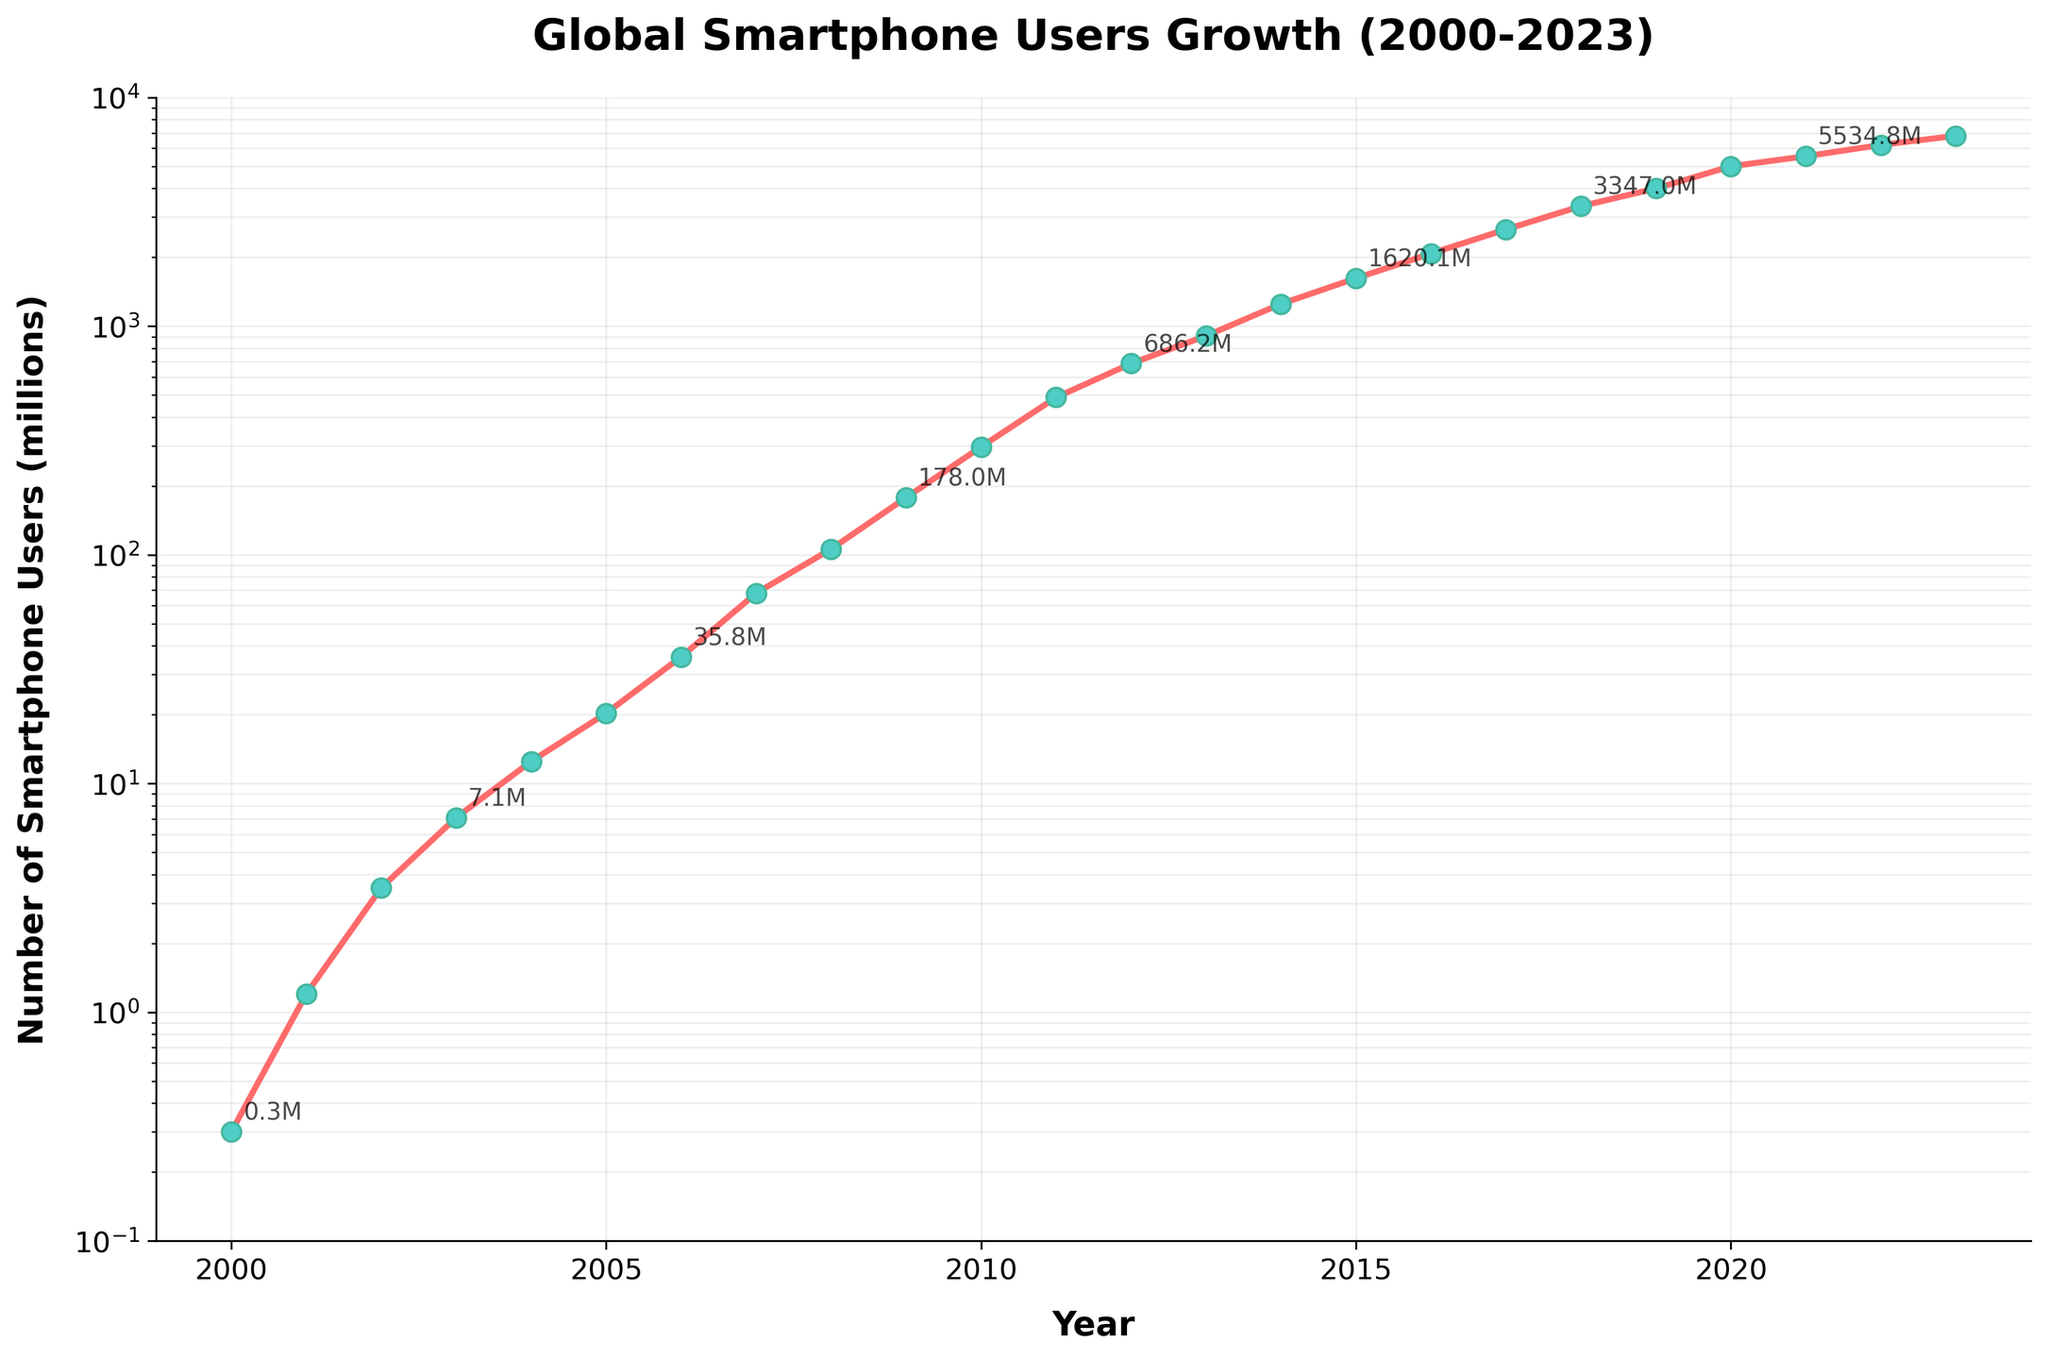What's the title of this figure? The title of the figure is displayed at the top, usually in a larger and bolder font compared to the other text elements. The title provides an overview of what the figure represents.
Answer: Global Smartphone Users Growth (2000-2023) What is the scale of the y-axis in the figure? The y-axis uses a logarithmic scale which is indicated by the evenly spaced ticks representing exponential values. This is different from a linear scale where the spacing between numbers would be constant.
Answer: Logarithmic How many data points are plotted on the figure? The number of data points is determined by the number of distinct years listed on the x-axis, with a corresponding number of users for each year. The range is from 2000 to 2023 inclusive. By counting the years, we identify 24 data points.
Answer: 24 Which year marked approximately 1000 million smartphone users globally? We locate the year corresponding to the y-axis value close to 1000 million by following a straight line from the 1000 million mark until it intersects the plotted line. The annotation or the position of the data point will help determine the exact year.
Answer: 2013 What was the growth in the number of smartphone users from 2010 to 2011? First, identify the number of users in 2010 and 2011 from the annotations or the plotted points: 296.6 million in 2010 and 487.9 million in 2011. Calculate the difference: 487.9 - 296.6.
Answer: 191.3 million Between which two consecutive years did the number of smartphone users increase the most? Examine the plotted points to find the largest vertical gap between consecutive years. Calculate the differences for each pair of years, then identify the maximum difference. The largest increase appears between 2019 (4000.5 million) and 2020 (5000.0 million): 5000.0 - 4000.5 = 999.5 million.
Answer: 2019 and 2020 What is the general trend of smartphone user growth from 2000 to 2023? Observing the overall shape of the line plot, the trend indicates a general increase, confirmed by the consistent upward direction of the plotted line from left to right. The logarithmic y-axis shows exponential growth, reflected by the steep slope of the line.
Answer: Increasing Which period had a more rapid growth, 2000-2010 or 2010-2020? Measure the growth over each period by calculating the difference in the number of users at the start and end of each period. For 2000-2010: 296.6 - 0.3 = 296.3 million. For 2010-2020: 5000.0 - 296.6 = 4703.4 million. Compare these two values to see which is greater.
Answer: 2010-2020 What was the approximate number of smartphone users in 2015? Check the position of the plotted data point or annotation for the year 2015 along the x-axis, then read the corresponding y-axis value. The approximate value should be near 1620.1 million as indicated in the data.
Answer: 1620.1 million 